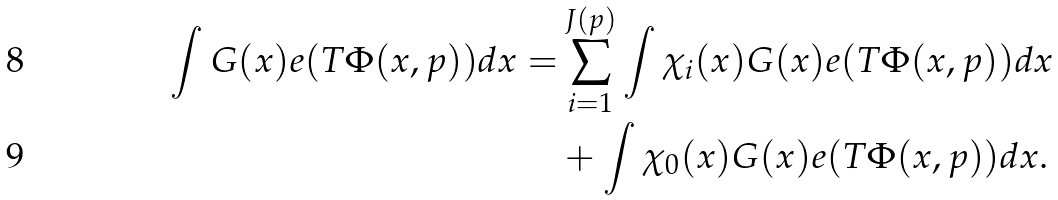<formula> <loc_0><loc_0><loc_500><loc_500>\int G ( x ) e ( T \Phi ( x , p ) ) d x = & \sum _ { i = 1 } ^ { J ( p ) } \int \chi _ { i } ( x ) G ( x ) e ( T \Phi ( x , p ) ) d x \\ & + \int \chi _ { 0 } ( x ) G ( x ) e ( T \Phi ( x , p ) ) d x .</formula> 